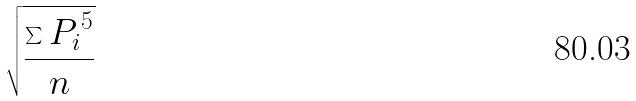Convert formula to latex. <formula><loc_0><loc_0><loc_500><loc_500>\sqrt { \frac { \sum { P _ { i } } ^ { 5 } } { n } }</formula> 